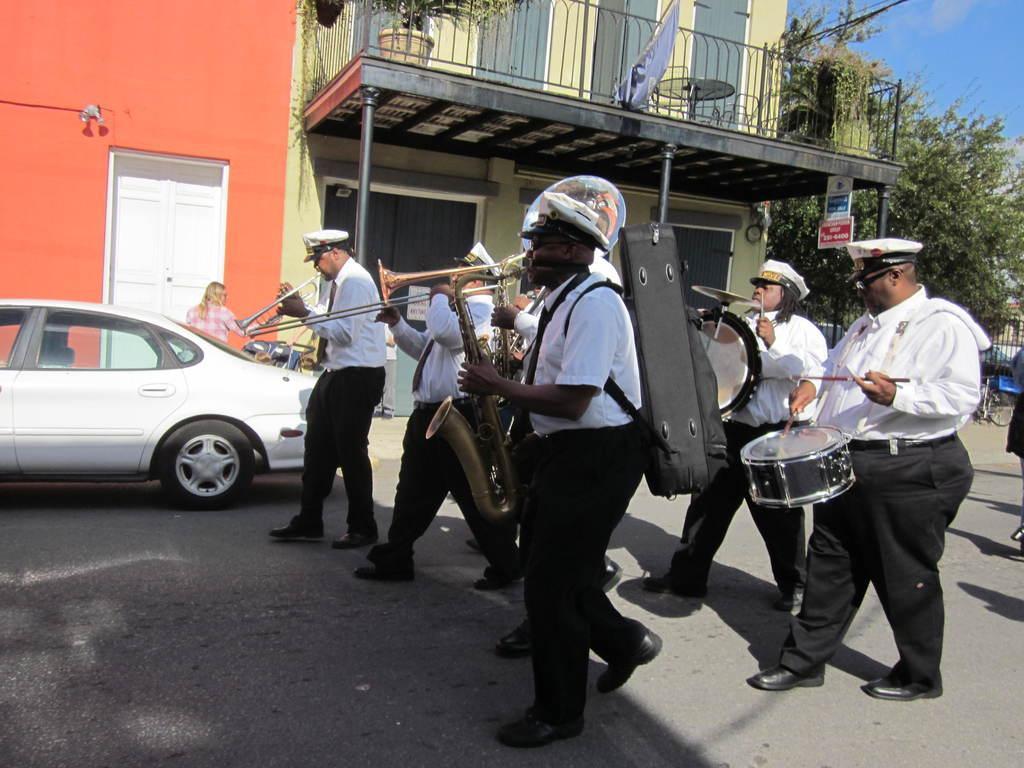Could you give a brief overview of what you see in this image? This picture shows group of people holding musical instruments and moving on the road and we see a car parked on the side and we see a building and trees and blue cloudy sky. 